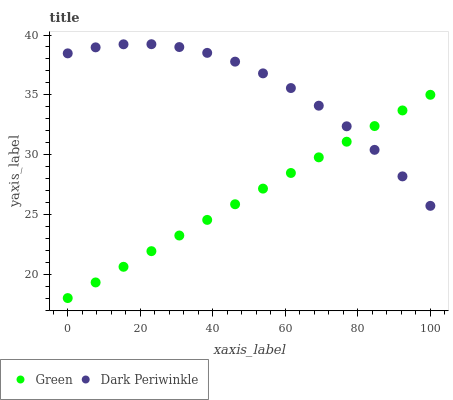Does Green have the minimum area under the curve?
Answer yes or no. Yes. Does Dark Periwinkle have the maximum area under the curve?
Answer yes or no. Yes. Does Dark Periwinkle have the minimum area under the curve?
Answer yes or no. No. Is Green the smoothest?
Answer yes or no. Yes. Is Dark Periwinkle the roughest?
Answer yes or no. Yes. Is Dark Periwinkle the smoothest?
Answer yes or no. No. Does Green have the lowest value?
Answer yes or no. Yes. Does Dark Periwinkle have the lowest value?
Answer yes or no. No. Does Dark Periwinkle have the highest value?
Answer yes or no. Yes. Does Dark Periwinkle intersect Green?
Answer yes or no. Yes. Is Dark Periwinkle less than Green?
Answer yes or no. No. Is Dark Periwinkle greater than Green?
Answer yes or no. No. 